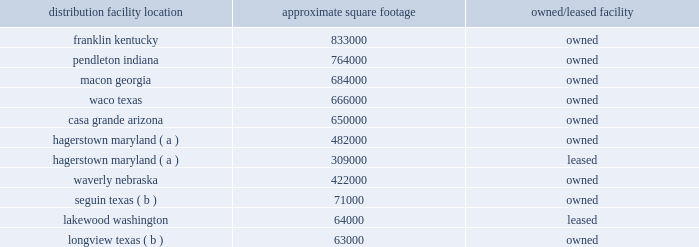The following is a list of distribution locations including the approximate square footage and if the location is leased or owned: .
Longview , texas ( b ) 63000 owned ( a ) the leased facility in hagerstown is treated as an extension of the existing owned hagerstown location and is not considered a separate distribution center .
( b ) this is a mixing center designed to process certain high-volume bulk products .
The company 2019s store support center occupies approximately 260000 square feet of owned building space in brentwood , tennessee , and the company 2019s merchandising innovation center occupies approximately 32000 square feet of leased building space in nashville , tennessee .
The company also leases approximately 8000 square feet of building space for the petsense corporate headquarters located in scottsdale , arizona .
In fiscal 2017 , we began construction on a new northeast distribution center in frankfort , new york , as well as an expansion of our existing distribution center in waverly , nebraska , which will provide additional distribution capacity once construction is completed .
Item 3 .
Legal proceedings item 103 of sec regulation s-k requires disclosure of certain environmental legal proceedings if the proceeding reasonably involves potential monetary sanctions of $ 100000 or more .
We periodically receive information requests and notices of potential noncompliance with environmental laws and regulations from governmental agencies , which are addressed on a case-by-case basis with the relevant agency .
The company received a subpoena from the district attorney of yolo county , california , requesting records and information regarding its hazardous waste management and disposal practices in california .
The company and the office of the district attorney of yolo county engaged in settlement discussions which resulted in the settlement of the matter .
A consent decree reflecting the terms of settlement was filed with the yolo county superior court on june 23 , 2017 .
Under the settlement , the company agreed to a compliance plan and also agreed to pay a civil penalty and fund supplemental environmental projects furthering consumer protection and environmental enforcement in california .
The civil penalty did not differ materially from the amount accrued .
The cost of the settlement and the compliance with the consent decree will not have a material effect on our consolidated financial position , results of operations or cash flows .
The company is also involved in various litigation matters arising in the ordinary course of business .
The company believes that any estimated loss related to such matters has been adequately provided for in accrued liabilities to the extent probable and reasonably estimable .
Accordingly , the company currently expects these matters will be resolved without material adverse effect on its consolidated financial position , results of operations or cash flows .
Item 4 .
Mine safety disclosures not applicable. .
What is the total square footage for the md facility? 
Computations: (482000 + 309000)
Answer: 791000.0. 